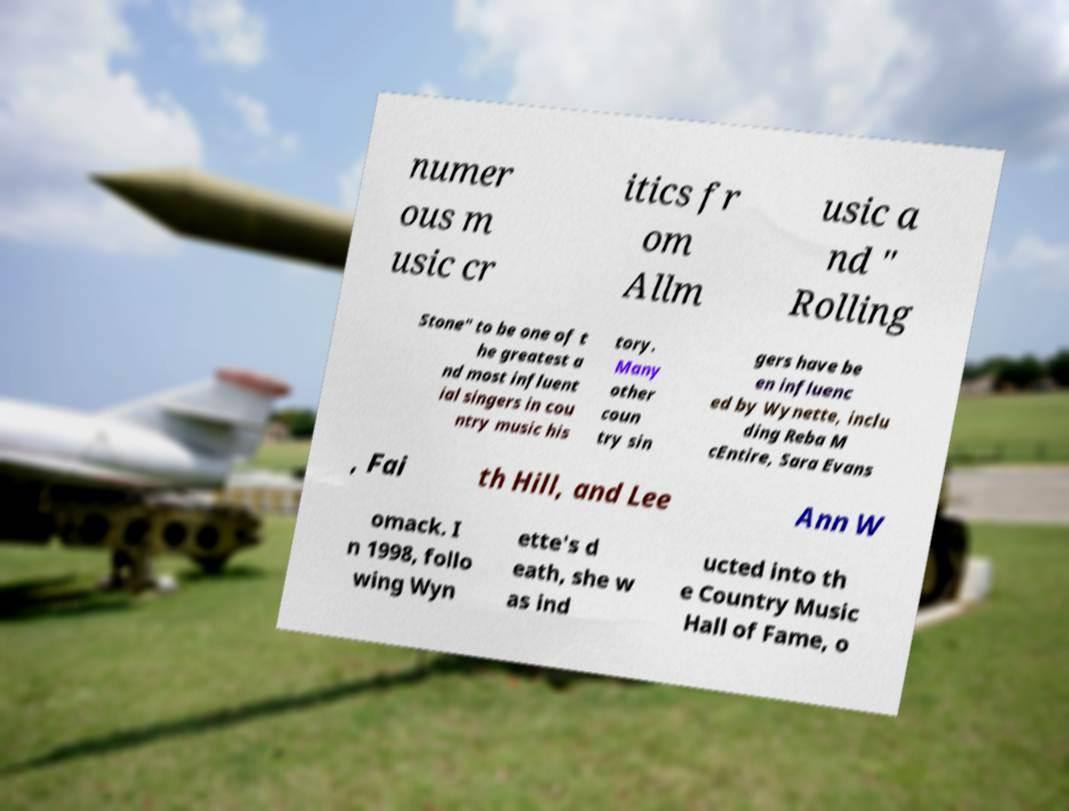Could you extract and type out the text from this image? numer ous m usic cr itics fr om Allm usic a nd " Rolling Stone" to be one of t he greatest a nd most influent ial singers in cou ntry music his tory. Many other coun try sin gers have be en influenc ed by Wynette, inclu ding Reba M cEntire, Sara Evans , Fai th Hill, and Lee Ann W omack. I n 1998, follo wing Wyn ette's d eath, she w as ind ucted into th e Country Music Hall of Fame, o 